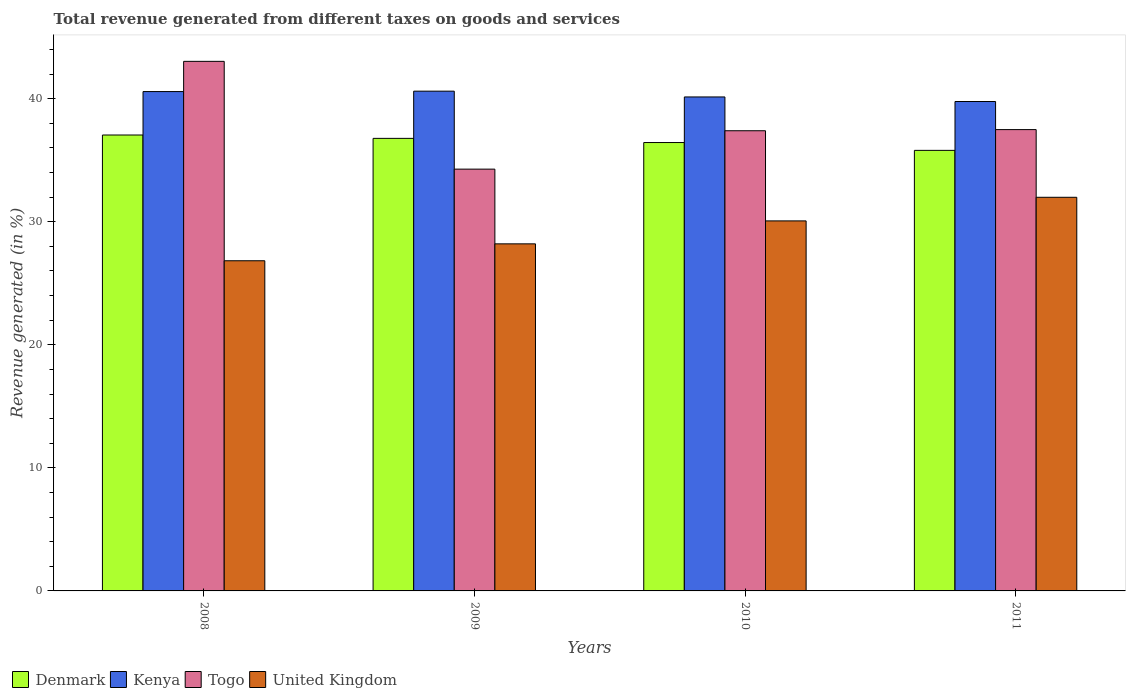How many different coloured bars are there?
Your answer should be very brief. 4. How many groups of bars are there?
Give a very brief answer. 4. Are the number of bars per tick equal to the number of legend labels?
Ensure brevity in your answer.  Yes. How many bars are there on the 3rd tick from the right?
Offer a very short reply. 4. In how many cases, is the number of bars for a given year not equal to the number of legend labels?
Offer a terse response. 0. What is the total revenue generated in Kenya in 2008?
Keep it short and to the point. 40.57. Across all years, what is the maximum total revenue generated in Kenya?
Your answer should be compact. 40.61. Across all years, what is the minimum total revenue generated in United Kingdom?
Your response must be concise. 26.83. What is the total total revenue generated in United Kingdom in the graph?
Offer a terse response. 117.08. What is the difference between the total revenue generated in Denmark in 2009 and that in 2011?
Your answer should be very brief. 0.97. What is the difference between the total revenue generated in Denmark in 2011 and the total revenue generated in Kenya in 2008?
Keep it short and to the point. -4.78. What is the average total revenue generated in Togo per year?
Make the answer very short. 38.04. In the year 2011, what is the difference between the total revenue generated in Togo and total revenue generated in Kenya?
Keep it short and to the point. -2.28. In how many years, is the total revenue generated in United Kingdom greater than 2 %?
Your response must be concise. 4. What is the ratio of the total revenue generated in United Kingdom in 2008 to that in 2011?
Provide a succinct answer. 0.84. What is the difference between the highest and the second highest total revenue generated in Kenya?
Make the answer very short. 0.03. What is the difference between the highest and the lowest total revenue generated in Kenya?
Make the answer very short. 0.84. Is the sum of the total revenue generated in Denmark in 2008 and 2011 greater than the maximum total revenue generated in Kenya across all years?
Your answer should be compact. Yes. What does the 1st bar from the left in 2008 represents?
Provide a succinct answer. Denmark. How many bars are there?
Provide a succinct answer. 16. Are all the bars in the graph horizontal?
Offer a terse response. No. How many years are there in the graph?
Offer a very short reply. 4. Are the values on the major ticks of Y-axis written in scientific E-notation?
Your answer should be very brief. No. Does the graph contain any zero values?
Ensure brevity in your answer.  No. Does the graph contain grids?
Offer a terse response. No. How are the legend labels stacked?
Your answer should be very brief. Horizontal. What is the title of the graph?
Your answer should be very brief. Total revenue generated from different taxes on goods and services. What is the label or title of the Y-axis?
Make the answer very short. Revenue generated (in %). What is the Revenue generated (in %) of Denmark in 2008?
Make the answer very short. 37.04. What is the Revenue generated (in %) of Kenya in 2008?
Give a very brief answer. 40.57. What is the Revenue generated (in %) in Togo in 2008?
Offer a very short reply. 43.03. What is the Revenue generated (in %) in United Kingdom in 2008?
Make the answer very short. 26.83. What is the Revenue generated (in %) of Denmark in 2009?
Your answer should be compact. 36.77. What is the Revenue generated (in %) in Kenya in 2009?
Provide a succinct answer. 40.61. What is the Revenue generated (in %) of Togo in 2009?
Your answer should be very brief. 34.27. What is the Revenue generated (in %) of United Kingdom in 2009?
Your answer should be very brief. 28.2. What is the Revenue generated (in %) in Denmark in 2010?
Give a very brief answer. 36.43. What is the Revenue generated (in %) in Kenya in 2010?
Provide a succinct answer. 40.14. What is the Revenue generated (in %) of Togo in 2010?
Your answer should be compact. 37.39. What is the Revenue generated (in %) in United Kingdom in 2010?
Provide a succinct answer. 30.07. What is the Revenue generated (in %) in Denmark in 2011?
Offer a terse response. 35.8. What is the Revenue generated (in %) of Kenya in 2011?
Ensure brevity in your answer.  39.77. What is the Revenue generated (in %) of Togo in 2011?
Make the answer very short. 37.48. What is the Revenue generated (in %) of United Kingdom in 2011?
Provide a short and direct response. 31.98. Across all years, what is the maximum Revenue generated (in %) in Denmark?
Your answer should be compact. 37.04. Across all years, what is the maximum Revenue generated (in %) of Kenya?
Your response must be concise. 40.61. Across all years, what is the maximum Revenue generated (in %) of Togo?
Give a very brief answer. 43.03. Across all years, what is the maximum Revenue generated (in %) of United Kingdom?
Keep it short and to the point. 31.98. Across all years, what is the minimum Revenue generated (in %) in Denmark?
Ensure brevity in your answer.  35.8. Across all years, what is the minimum Revenue generated (in %) in Kenya?
Make the answer very short. 39.77. Across all years, what is the minimum Revenue generated (in %) of Togo?
Provide a succinct answer. 34.27. Across all years, what is the minimum Revenue generated (in %) of United Kingdom?
Your response must be concise. 26.83. What is the total Revenue generated (in %) in Denmark in the graph?
Make the answer very short. 146.05. What is the total Revenue generated (in %) of Kenya in the graph?
Give a very brief answer. 161.09. What is the total Revenue generated (in %) in Togo in the graph?
Your answer should be compact. 152.18. What is the total Revenue generated (in %) of United Kingdom in the graph?
Your answer should be compact. 117.08. What is the difference between the Revenue generated (in %) of Denmark in 2008 and that in 2009?
Keep it short and to the point. 0.27. What is the difference between the Revenue generated (in %) of Kenya in 2008 and that in 2009?
Ensure brevity in your answer.  -0.03. What is the difference between the Revenue generated (in %) of Togo in 2008 and that in 2009?
Make the answer very short. 8.76. What is the difference between the Revenue generated (in %) in United Kingdom in 2008 and that in 2009?
Your response must be concise. -1.37. What is the difference between the Revenue generated (in %) of Denmark in 2008 and that in 2010?
Offer a very short reply. 0.61. What is the difference between the Revenue generated (in %) in Kenya in 2008 and that in 2010?
Give a very brief answer. 0.44. What is the difference between the Revenue generated (in %) of Togo in 2008 and that in 2010?
Keep it short and to the point. 5.64. What is the difference between the Revenue generated (in %) of United Kingdom in 2008 and that in 2010?
Your answer should be compact. -3.24. What is the difference between the Revenue generated (in %) in Denmark in 2008 and that in 2011?
Offer a very short reply. 1.25. What is the difference between the Revenue generated (in %) in Kenya in 2008 and that in 2011?
Offer a terse response. 0.81. What is the difference between the Revenue generated (in %) in Togo in 2008 and that in 2011?
Your answer should be compact. 5.54. What is the difference between the Revenue generated (in %) in United Kingdom in 2008 and that in 2011?
Ensure brevity in your answer.  -5.16. What is the difference between the Revenue generated (in %) in Denmark in 2009 and that in 2010?
Ensure brevity in your answer.  0.34. What is the difference between the Revenue generated (in %) of Kenya in 2009 and that in 2010?
Your response must be concise. 0.47. What is the difference between the Revenue generated (in %) in Togo in 2009 and that in 2010?
Ensure brevity in your answer.  -3.12. What is the difference between the Revenue generated (in %) of United Kingdom in 2009 and that in 2010?
Keep it short and to the point. -1.86. What is the difference between the Revenue generated (in %) in Denmark in 2009 and that in 2011?
Offer a terse response. 0.97. What is the difference between the Revenue generated (in %) of Kenya in 2009 and that in 2011?
Offer a terse response. 0.84. What is the difference between the Revenue generated (in %) of Togo in 2009 and that in 2011?
Offer a very short reply. -3.21. What is the difference between the Revenue generated (in %) of United Kingdom in 2009 and that in 2011?
Keep it short and to the point. -3.78. What is the difference between the Revenue generated (in %) in Denmark in 2010 and that in 2011?
Provide a succinct answer. 0.64. What is the difference between the Revenue generated (in %) in Kenya in 2010 and that in 2011?
Offer a terse response. 0.37. What is the difference between the Revenue generated (in %) in Togo in 2010 and that in 2011?
Give a very brief answer. -0.09. What is the difference between the Revenue generated (in %) in United Kingdom in 2010 and that in 2011?
Offer a terse response. -1.92. What is the difference between the Revenue generated (in %) in Denmark in 2008 and the Revenue generated (in %) in Kenya in 2009?
Provide a short and direct response. -3.56. What is the difference between the Revenue generated (in %) of Denmark in 2008 and the Revenue generated (in %) of Togo in 2009?
Offer a terse response. 2.77. What is the difference between the Revenue generated (in %) of Denmark in 2008 and the Revenue generated (in %) of United Kingdom in 2009?
Ensure brevity in your answer.  8.84. What is the difference between the Revenue generated (in %) in Kenya in 2008 and the Revenue generated (in %) in Togo in 2009?
Ensure brevity in your answer.  6.3. What is the difference between the Revenue generated (in %) of Kenya in 2008 and the Revenue generated (in %) of United Kingdom in 2009?
Give a very brief answer. 12.37. What is the difference between the Revenue generated (in %) in Togo in 2008 and the Revenue generated (in %) in United Kingdom in 2009?
Give a very brief answer. 14.83. What is the difference between the Revenue generated (in %) in Denmark in 2008 and the Revenue generated (in %) in Kenya in 2010?
Keep it short and to the point. -3.09. What is the difference between the Revenue generated (in %) in Denmark in 2008 and the Revenue generated (in %) in Togo in 2010?
Offer a terse response. -0.35. What is the difference between the Revenue generated (in %) of Denmark in 2008 and the Revenue generated (in %) of United Kingdom in 2010?
Your answer should be compact. 6.98. What is the difference between the Revenue generated (in %) of Kenya in 2008 and the Revenue generated (in %) of Togo in 2010?
Provide a short and direct response. 3.18. What is the difference between the Revenue generated (in %) of Kenya in 2008 and the Revenue generated (in %) of United Kingdom in 2010?
Offer a very short reply. 10.51. What is the difference between the Revenue generated (in %) in Togo in 2008 and the Revenue generated (in %) in United Kingdom in 2010?
Your answer should be very brief. 12.96. What is the difference between the Revenue generated (in %) of Denmark in 2008 and the Revenue generated (in %) of Kenya in 2011?
Give a very brief answer. -2.72. What is the difference between the Revenue generated (in %) in Denmark in 2008 and the Revenue generated (in %) in Togo in 2011?
Give a very brief answer. -0.44. What is the difference between the Revenue generated (in %) in Denmark in 2008 and the Revenue generated (in %) in United Kingdom in 2011?
Give a very brief answer. 5.06. What is the difference between the Revenue generated (in %) of Kenya in 2008 and the Revenue generated (in %) of Togo in 2011?
Your answer should be compact. 3.09. What is the difference between the Revenue generated (in %) in Kenya in 2008 and the Revenue generated (in %) in United Kingdom in 2011?
Give a very brief answer. 8.59. What is the difference between the Revenue generated (in %) in Togo in 2008 and the Revenue generated (in %) in United Kingdom in 2011?
Ensure brevity in your answer.  11.05. What is the difference between the Revenue generated (in %) of Denmark in 2009 and the Revenue generated (in %) of Kenya in 2010?
Offer a terse response. -3.37. What is the difference between the Revenue generated (in %) of Denmark in 2009 and the Revenue generated (in %) of Togo in 2010?
Provide a succinct answer. -0.62. What is the difference between the Revenue generated (in %) of Denmark in 2009 and the Revenue generated (in %) of United Kingdom in 2010?
Your answer should be compact. 6.71. What is the difference between the Revenue generated (in %) in Kenya in 2009 and the Revenue generated (in %) in Togo in 2010?
Give a very brief answer. 3.22. What is the difference between the Revenue generated (in %) in Kenya in 2009 and the Revenue generated (in %) in United Kingdom in 2010?
Offer a very short reply. 10.54. What is the difference between the Revenue generated (in %) of Togo in 2009 and the Revenue generated (in %) of United Kingdom in 2010?
Your answer should be very brief. 4.21. What is the difference between the Revenue generated (in %) in Denmark in 2009 and the Revenue generated (in %) in Kenya in 2011?
Your answer should be compact. -3. What is the difference between the Revenue generated (in %) of Denmark in 2009 and the Revenue generated (in %) of Togo in 2011?
Offer a very short reply. -0.71. What is the difference between the Revenue generated (in %) of Denmark in 2009 and the Revenue generated (in %) of United Kingdom in 2011?
Provide a succinct answer. 4.79. What is the difference between the Revenue generated (in %) of Kenya in 2009 and the Revenue generated (in %) of Togo in 2011?
Your answer should be compact. 3.12. What is the difference between the Revenue generated (in %) in Kenya in 2009 and the Revenue generated (in %) in United Kingdom in 2011?
Ensure brevity in your answer.  8.62. What is the difference between the Revenue generated (in %) of Togo in 2009 and the Revenue generated (in %) of United Kingdom in 2011?
Your answer should be very brief. 2.29. What is the difference between the Revenue generated (in %) of Denmark in 2010 and the Revenue generated (in %) of Kenya in 2011?
Your response must be concise. -3.33. What is the difference between the Revenue generated (in %) in Denmark in 2010 and the Revenue generated (in %) in Togo in 2011?
Offer a very short reply. -1.05. What is the difference between the Revenue generated (in %) of Denmark in 2010 and the Revenue generated (in %) of United Kingdom in 2011?
Give a very brief answer. 4.45. What is the difference between the Revenue generated (in %) of Kenya in 2010 and the Revenue generated (in %) of Togo in 2011?
Your answer should be compact. 2.65. What is the difference between the Revenue generated (in %) in Kenya in 2010 and the Revenue generated (in %) in United Kingdom in 2011?
Your answer should be compact. 8.15. What is the difference between the Revenue generated (in %) in Togo in 2010 and the Revenue generated (in %) in United Kingdom in 2011?
Offer a very short reply. 5.41. What is the average Revenue generated (in %) of Denmark per year?
Provide a succinct answer. 36.51. What is the average Revenue generated (in %) of Kenya per year?
Offer a terse response. 40.27. What is the average Revenue generated (in %) in Togo per year?
Keep it short and to the point. 38.04. What is the average Revenue generated (in %) of United Kingdom per year?
Your answer should be very brief. 29.27. In the year 2008, what is the difference between the Revenue generated (in %) in Denmark and Revenue generated (in %) in Kenya?
Keep it short and to the point. -3.53. In the year 2008, what is the difference between the Revenue generated (in %) in Denmark and Revenue generated (in %) in Togo?
Offer a very short reply. -5.99. In the year 2008, what is the difference between the Revenue generated (in %) of Denmark and Revenue generated (in %) of United Kingdom?
Your response must be concise. 10.22. In the year 2008, what is the difference between the Revenue generated (in %) of Kenya and Revenue generated (in %) of Togo?
Your answer should be compact. -2.45. In the year 2008, what is the difference between the Revenue generated (in %) of Kenya and Revenue generated (in %) of United Kingdom?
Make the answer very short. 13.75. In the year 2008, what is the difference between the Revenue generated (in %) of Togo and Revenue generated (in %) of United Kingdom?
Give a very brief answer. 16.2. In the year 2009, what is the difference between the Revenue generated (in %) of Denmark and Revenue generated (in %) of Kenya?
Ensure brevity in your answer.  -3.84. In the year 2009, what is the difference between the Revenue generated (in %) in Denmark and Revenue generated (in %) in Togo?
Your response must be concise. 2.5. In the year 2009, what is the difference between the Revenue generated (in %) in Denmark and Revenue generated (in %) in United Kingdom?
Give a very brief answer. 8.57. In the year 2009, what is the difference between the Revenue generated (in %) in Kenya and Revenue generated (in %) in Togo?
Give a very brief answer. 6.34. In the year 2009, what is the difference between the Revenue generated (in %) of Kenya and Revenue generated (in %) of United Kingdom?
Your response must be concise. 12.41. In the year 2009, what is the difference between the Revenue generated (in %) of Togo and Revenue generated (in %) of United Kingdom?
Keep it short and to the point. 6.07. In the year 2010, what is the difference between the Revenue generated (in %) of Denmark and Revenue generated (in %) of Kenya?
Ensure brevity in your answer.  -3.7. In the year 2010, what is the difference between the Revenue generated (in %) in Denmark and Revenue generated (in %) in Togo?
Your response must be concise. -0.96. In the year 2010, what is the difference between the Revenue generated (in %) of Denmark and Revenue generated (in %) of United Kingdom?
Offer a very short reply. 6.37. In the year 2010, what is the difference between the Revenue generated (in %) of Kenya and Revenue generated (in %) of Togo?
Give a very brief answer. 2.75. In the year 2010, what is the difference between the Revenue generated (in %) in Kenya and Revenue generated (in %) in United Kingdom?
Keep it short and to the point. 10.07. In the year 2010, what is the difference between the Revenue generated (in %) in Togo and Revenue generated (in %) in United Kingdom?
Make the answer very short. 7.33. In the year 2011, what is the difference between the Revenue generated (in %) of Denmark and Revenue generated (in %) of Kenya?
Provide a succinct answer. -3.97. In the year 2011, what is the difference between the Revenue generated (in %) of Denmark and Revenue generated (in %) of Togo?
Provide a short and direct response. -1.69. In the year 2011, what is the difference between the Revenue generated (in %) of Denmark and Revenue generated (in %) of United Kingdom?
Ensure brevity in your answer.  3.81. In the year 2011, what is the difference between the Revenue generated (in %) of Kenya and Revenue generated (in %) of Togo?
Your response must be concise. 2.28. In the year 2011, what is the difference between the Revenue generated (in %) of Kenya and Revenue generated (in %) of United Kingdom?
Your response must be concise. 7.78. In the year 2011, what is the difference between the Revenue generated (in %) of Togo and Revenue generated (in %) of United Kingdom?
Your response must be concise. 5.5. What is the ratio of the Revenue generated (in %) in Denmark in 2008 to that in 2009?
Your answer should be compact. 1.01. What is the ratio of the Revenue generated (in %) in Kenya in 2008 to that in 2009?
Your response must be concise. 1. What is the ratio of the Revenue generated (in %) in Togo in 2008 to that in 2009?
Provide a succinct answer. 1.26. What is the ratio of the Revenue generated (in %) in United Kingdom in 2008 to that in 2009?
Your answer should be compact. 0.95. What is the ratio of the Revenue generated (in %) in Denmark in 2008 to that in 2010?
Provide a short and direct response. 1.02. What is the ratio of the Revenue generated (in %) of Kenya in 2008 to that in 2010?
Offer a very short reply. 1.01. What is the ratio of the Revenue generated (in %) in Togo in 2008 to that in 2010?
Provide a succinct answer. 1.15. What is the ratio of the Revenue generated (in %) in United Kingdom in 2008 to that in 2010?
Offer a terse response. 0.89. What is the ratio of the Revenue generated (in %) of Denmark in 2008 to that in 2011?
Your answer should be very brief. 1.03. What is the ratio of the Revenue generated (in %) in Kenya in 2008 to that in 2011?
Give a very brief answer. 1.02. What is the ratio of the Revenue generated (in %) in Togo in 2008 to that in 2011?
Give a very brief answer. 1.15. What is the ratio of the Revenue generated (in %) of United Kingdom in 2008 to that in 2011?
Your answer should be compact. 0.84. What is the ratio of the Revenue generated (in %) of Denmark in 2009 to that in 2010?
Provide a succinct answer. 1.01. What is the ratio of the Revenue generated (in %) of Kenya in 2009 to that in 2010?
Give a very brief answer. 1.01. What is the ratio of the Revenue generated (in %) of Togo in 2009 to that in 2010?
Provide a succinct answer. 0.92. What is the ratio of the Revenue generated (in %) in United Kingdom in 2009 to that in 2010?
Provide a succinct answer. 0.94. What is the ratio of the Revenue generated (in %) in Denmark in 2009 to that in 2011?
Provide a short and direct response. 1.03. What is the ratio of the Revenue generated (in %) in Kenya in 2009 to that in 2011?
Provide a short and direct response. 1.02. What is the ratio of the Revenue generated (in %) of Togo in 2009 to that in 2011?
Offer a very short reply. 0.91. What is the ratio of the Revenue generated (in %) in United Kingdom in 2009 to that in 2011?
Give a very brief answer. 0.88. What is the ratio of the Revenue generated (in %) of Denmark in 2010 to that in 2011?
Your answer should be compact. 1.02. What is the ratio of the Revenue generated (in %) of Kenya in 2010 to that in 2011?
Your answer should be very brief. 1.01. What is the ratio of the Revenue generated (in %) in Togo in 2010 to that in 2011?
Your response must be concise. 1. What is the difference between the highest and the second highest Revenue generated (in %) in Denmark?
Provide a succinct answer. 0.27. What is the difference between the highest and the second highest Revenue generated (in %) in Kenya?
Your answer should be very brief. 0.03. What is the difference between the highest and the second highest Revenue generated (in %) in Togo?
Keep it short and to the point. 5.54. What is the difference between the highest and the second highest Revenue generated (in %) of United Kingdom?
Provide a succinct answer. 1.92. What is the difference between the highest and the lowest Revenue generated (in %) of Denmark?
Your answer should be compact. 1.25. What is the difference between the highest and the lowest Revenue generated (in %) in Kenya?
Your answer should be very brief. 0.84. What is the difference between the highest and the lowest Revenue generated (in %) in Togo?
Make the answer very short. 8.76. What is the difference between the highest and the lowest Revenue generated (in %) of United Kingdom?
Your answer should be compact. 5.16. 